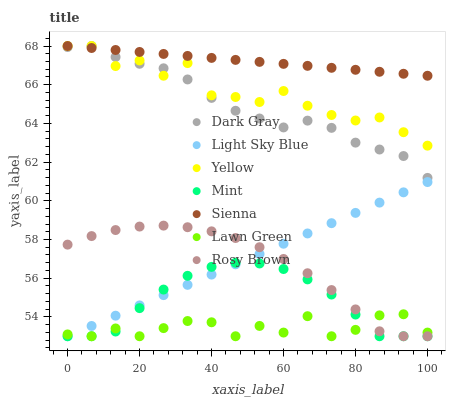Does Lawn Green have the minimum area under the curve?
Answer yes or no. Yes. Does Sienna have the maximum area under the curve?
Answer yes or no. Yes. Does Rosy Brown have the minimum area under the curve?
Answer yes or no. No. Does Rosy Brown have the maximum area under the curve?
Answer yes or no. No. Is Light Sky Blue the smoothest?
Answer yes or no. Yes. Is Yellow the roughest?
Answer yes or no. Yes. Is Lawn Green the smoothest?
Answer yes or no. No. Is Lawn Green the roughest?
Answer yes or no. No. Does Lawn Green have the lowest value?
Answer yes or no. Yes. Does Yellow have the lowest value?
Answer yes or no. No. Does Dark Gray have the highest value?
Answer yes or no. Yes. Does Rosy Brown have the highest value?
Answer yes or no. No. Is Light Sky Blue less than Dark Gray?
Answer yes or no. Yes. Is Dark Gray greater than Rosy Brown?
Answer yes or no. Yes. Does Light Sky Blue intersect Mint?
Answer yes or no. Yes. Is Light Sky Blue less than Mint?
Answer yes or no. No. Is Light Sky Blue greater than Mint?
Answer yes or no. No. Does Light Sky Blue intersect Dark Gray?
Answer yes or no. No. 